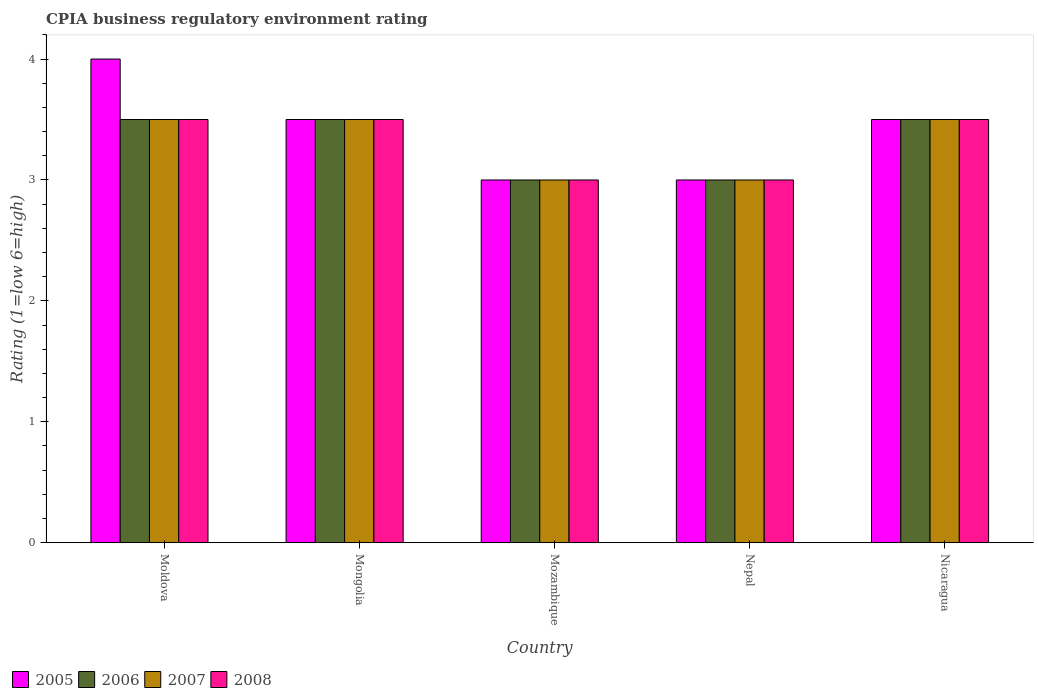How many different coloured bars are there?
Keep it short and to the point. 4. How many groups of bars are there?
Your answer should be compact. 5. How many bars are there on the 5th tick from the left?
Ensure brevity in your answer.  4. How many bars are there on the 1st tick from the right?
Provide a short and direct response. 4. What is the label of the 3rd group of bars from the left?
Your answer should be compact. Mozambique. In how many cases, is the number of bars for a given country not equal to the number of legend labels?
Provide a short and direct response. 0. In which country was the CPIA rating in 2008 maximum?
Offer a very short reply. Moldova. In which country was the CPIA rating in 2006 minimum?
Your response must be concise. Mozambique. What is the difference between the CPIA rating in 2006 in Moldova and that in Mongolia?
Your answer should be very brief. 0. What is the average CPIA rating in 2007 per country?
Offer a terse response. 3.3. What is the difference between the CPIA rating of/in 2006 and CPIA rating of/in 2007 in Mozambique?
Keep it short and to the point. 0. What is the ratio of the CPIA rating in 2005 in Mongolia to that in Mozambique?
Offer a terse response. 1.17. What is the difference between the highest and the lowest CPIA rating in 2007?
Your answer should be very brief. 0.5. Is the sum of the CPIA rating in 2006 in Nepal and Nicaragua greater than the maximum CPIA rating in 2008 across all countries?
Offer a terse response. Yes. Is it the case that in every country, the sum of the CPIA rating in 2007 and CPIA rating in 2006 is greater than the sum of CPIA rating in 2005 and CPIA rating in 2008?
Give a very brief answer. No. Is it the case that in every country, the sum of the CPIA rating in 2005 and CPIA rating in 2006 is greater than the CPIA rating in 2007?
Make the answer very short. Yes. Are all the bars in the graph horizontal?
Keep it short and to the point. No. How many countries are there in the graph?
Your answer should be very brief. 5. What is the difference between two consecutive major ticks on the Y-axis?
Make the answer very short. 1. Does the graph contain any zero values?
Your response must be concise. No. Does the graph contain grids?
Your response must be concise. No. How many legend labels are there?
Provide a succinct answer. 4. How are the legend labels stacked?
Offer a very short reply. Horizontal. What is the title of the graph?
Ensure brevity in your answer.  CPIA business regulatory environment rating. Does "2015" appear as one of the legend labels in the graph?
Your answer should be compact. No. What is the label or title of the X-axis?
Offer a terse response. Country. What is the Rating (1=low 6=high) in 2005 in Moldova?
Your response must be concise. 4. What is the Rating (1=low 6=high) of 2006 in Moldova?
Offer a very short reply. 3.5. What is the Rating (1=low 6=high) of 2007 in Moldova?
Give a very brief answer. 3.5. What is the Rating (1=low 6=high) of 2008 in Moldova?
Your answer should be compact. 3.5. What is the Rating (1=low 6=high) of 2005 in Mongolia?
Your answer should be very brief. 3.5. What is the Rating (1=low 6=high) of 2008 in Mongolia?
Offer a terse response. 3.5. What is the Rating (1=low 6=high) of 2005 in Mozambique?
Provide a short and direct response. 3. What is the Rating (1=low 6=high) of 2005 in Nepal?
Make the answer very short. 3. What is the Rating (1=low 6=high) in 2006 in Nepal?
Provide a succinct answer. 3. What is the Rating (1=low 6=high) of 2007 in Nicaragua?
Your answer should be very brief. 3.5. Across all countries, what is the maximum Rating (1=low 6=high) of 2005?
Offer a terse response. 4. Across all countries, what is the maximum Rating (1=low 6=high) of 2006?
Give a very brief answer. 3.5. Across all countries, what is the maximum Rating (1=low 6=high) of 2007?
Your answer should be compact. 3.5. Across all countries, what is the minimum Rating (1=low 6=high) of 2006?
Your answer should be compact. 3. What is the total Rating (1=low 6=high) in 2006 in the graph?
Offer a terse response. 16.5. What is the difference between the Rating (1=low 6=high) of 2005 in Moldova and that in Mongolia?
Provide a succinct answer. 0.5. What is the difference between the Rating (1=low 6=high) in 2006 in Moldova and that in Mongolia?
Your answer should be compact. 0. What is the difference between the Rating (1=low 6=high) in 2008 in Moldova and that in Mongolia?
Give a very brief answer. 0. What is the difference between the Rating (1=low 6=high) in 2005 in Moldova and that in Mozambique?
Your response must be concise. 1. What is the difference between the Rating (1=low 6=high) in 2006 in Moldova and that in Mozambique?
Your response must be concise. 0.5. What is the difference between the Rating (1=low 6=high) in 2007 in Moldova and that in Mozambique?
Give a very brief answer. 0.5. What is the difference between the Rating (1=low 6=high) of 2008 in Moldova and that in Mozambique?
Your answer should be compact. 0.5. What is the difference between the Rating (1=low 6=high) in 2005 in Moldova and that in Nepal?
Your answer should be compact. 1. What is the difference between the Rating (1=low 6=high) in 2008 in Moldova and that in Nepal?
Provide a short and direct response. 0.5. What is the difference between the Rating (1=low 6=high) in 2006 in Moldova and that in Nicaragua?
Your answer should be compact. 0. What is the difference between the Rating (1=low 6=high) in 2007 in Moldova and that in Nicaragua?
Your answer should be compact. 0. What is the difference between the Rating (1=low 6=high) in 2005 in Mongolia and that in Mozambique?
Give a very brief answer. 0.5. What is the difference between the Rating (1=low 6=high) of 2007 in Mongolia and that in Mozambique?
Ensure brevity in your answer.  0.5. What is the difference between the Rating (1=low 6=high) in 2006 in Mongolia and that in Nepal?
Provide a short and direct response. 0.5. What is the difference between the Rating (1=low 6=high) in 2006 in Mongolia and that in Nicaragua?
Offer a terse response. 0. What is the difference between the Rating (1=low 6=high) of 2005 in Mozambique and that in Nepal?
Provide a short and direct response. 0. What is the difference between the Rating (1=low 6=high) of 2007 in Mozambique and that in Nepal?
Give a very brief answer. 0. What is the difference between the Rating (1=low 6=high) in 2008 in Mozambique and that in Nepal?
Your answer should be compact. 0. What is the difference between the Rating (1=low 6=high) in 2005 in Mozambique and that in Nicaragua?
Your answer should be very brief. -0.5. What is the difference between the Rating (1=low 6=high) of 2006 in Mozambique and that in Nicaragua?
Give a very brief answer. -0.5. What is the difference between the Rating (1=low 6=high) of 2007 in Mozambique and that in Nicaragua?
Offer a terse response. -0.5. What is the difference between the Rating (1=low 6=high) in 2008 in Mozambique and that in Nicaragua?
Give a very brief answer. -0.5. What is the difference between the Rating (1=low 6=high) of 2006 in Nepal and that in Nicaragua?
Give a very brief answer. -0.5. What is the difference between the Rating (1=low 6=high) in 2008 in Nepal and that in Nicaragua?
Your answer should be compact. -0.5. What is the difference between the Rating (1=low 6=high) of 2005 in Moldova and the Rating (1=low 6=high) of 2006 in Mongolia?
Provide a succinct answer. 0.5. What is the difference between the Rating (1=low 6=high) of 2005 in Moldova and the Rating (1=low 6=high) of 2007 in Mongolia?
Your answer should be very brief. 0.5. What is the difference between the Rating (1=low 6=high) in 2005 in Moldova and the Rating (1=low 6=high) in 2006 in Mozambique?
Provide a succinct answer. 1. What is the difference between the Rating (1=low 6=high) of 2006 in Moldova and the Rating (1=low 6=high) of 2008 in Mozambique?
Provide a short and direct response. 0.5. What is the difference between the Rating (1=low 6=high) in 2007 in Moldova and the Rating (1=low 6=high) in 2008 in Mozambique?
Ensure brevity in your answer.  0.5. What is the difference between the Rating (1=low 6=high) in 2005 in Moldova and the Rating (1=low 6=high) in 2007 in Nepal?
Your answer should be compact. 1. What is the difference between the Rating (1=low 6=high) in 2006 in Moldova and the Rating (1=low 6=high) in 2007 in Nepal?
Your answer should be compact. 0.5. What is the difference between the Rating (1=low 6=high) of 2007 in Moldova and the Rating (1=low 6=high) of 2008 in Nepal?
Your answer should be very brief. 0.5. What is the difference between the Rating (1=low 6=high) in 2005 in Moldova and the Rating (1=low 6=high) in 2006 in Nicaragua?
Provide a succinct answer. 0.5. What is the difference between the Rating (1=low 6=high) in 2005 in Moldova and the Rating (1=low 6=high) in 2008 in Nicaragua?
Your answer should be compact. 0.5. What is the difference between the Rating (1=low 6=high) in 2005 in Mongolia and the Rating (1=low 6=high) in 2007 in Mozambique?
Your answer should be compact. 0.5. What is the difference between the Rating (1=low 6=high) in 2005 in Mongolia and the Rating (1=low 6=high) in 2008 in Mozambique?
Offer a very short reply. 0.5. What is the difference between the Rating (1=low 6=high) of 2006 in Mongolia and the Rating (1=low 6=high) of 2007 in Mozambique?
Offer a very short reply. 0.5. What is the difference between the Rating (1=low 6=high) of 2007 in Mongolia and the Rating (1=low 6=high) of 2008 in Mozambique?
Keep it short and to the point. 0.5. What is the difference between the Rating (1=low 6=high) of 2005 in Mongolia and the Rating (1=low 6=high) of 2007 in Nepal?
Provide a succinct answer. 0.5. What is the difference between the Rating (1=low 6=high) of 2006 in Mongolia and the Rating (1=low 6=high) of 2008 in Nepal?
Your answer should be compact. 0.5. What is the difference between the Rating (1=low 6=high) in 2005 in Mongolia and the Rating (1=low 6=high) in 2006 in Nicaragua?
Provide a short and direct response. 0. What is the difference between the Rating (1=low 6=high) in 2005 in Mongolia and the Rating (1=low 6=high) in 2008 in Nicaragua?
Offer a terse response. 0. What is the difference between the Rating (1=low 6=high) of 2007 in Mongolia and the Rating (1=low 6=high) of 2008 in Nicaragua?
Your answer should be very brief. 0. What is the difference between the Rating (1=low 6=high) in 2005 in Mozambique and the Rating (1=low 6=high) in 2008 in Nepal?
Your response must be concise. 0. What is the difference between the Rating (1=low 6=high) of 2006 in Mozambique and the Rating (1=low 6=high) of 2008 in Nepal?
Make the answer very short. 0. What is the difference between the Rating (1=low 6=high) in 2007 in Mozambique and the Rating (1=low 6=high) in 2008 in Nepal?
Your answer should be very brief. 0. What is the difference between the Rating (1=low 6=high) in 2005 in Mozambique and the Rating (1=low 6=high) in 2006 in Nicaragua?
Offer a very short reply. -0.5. What is the difference between the Rating (1=low 6=high) in 2005 in Mozambique and the Rating (1=low 6=high) in 2008 in Nicaragua?
Give a very brief answer. -0.5. What is the difference between the Rating (1=low 6=high) of 2006 in Mozambique and the Rating (1=low 6=high) of 2007 in Nicaragua?
Offer a very short reply. -0.5. What is the difference between the Rating (1=low 6=high) of 2006 in Mozambique and the Rating (1=low 6=high) of 2008 in Nicaragua?
Keep it short and to the point. -0.5. What is the difference between the Rating (1=low 6=high) in 2005 in Nepal and the Rating (1=low 6=high) in 2006 in Nicaragua?
Ensure brevity in your answer.  -0.5. What is the difference between the Rating (1=low 6=high) in 2005 in Nepal and the Rating (1=low 6=high) in 2007 in Nicaragua?
Offer a very short reply. -0.5. What is the difference between the Rating (1=low 6=high) of 2006 in Nepal and the Rating (1=low 6=high) of 2008 in Nicaragua?
Offer a terse response. -0.5. What is the average Rating (1=low 6=high) in 2006 per country?
Your answer should be compact. 3.3. What is the average Rating (1=low 6=high) in 2008 per country?
Provide a short and direct response. 3.3. What is the difference between the Rating (1=low 6=high) of 2005 and Rating (1=low 6=high) of 2007 in Moldova?
Provide a short and direct response. 0.5. What is the difference between the Rating (1=low 6=high) in 2005 and Rating (1=low 6=high) in 2008 in Moldova?
Your answer should be compact. 0.5. What is the difference between the Rating (1=low 6=high) of 2006 and Rating (1=low 6=high) of 2007 in Moldova?
Ensure brevity in your answer.  0. What is the difference between the Rating (1=low 6=high) of 2006 and Rating (1=low 6=high) of 2008 in Moldova?
Provide a short and direct response. 0. What is the difference between the Rating (1=low 6=high) of 2007 and Rating (1=low 6=high) of 2008 in Moldova?
Keep it short and to the point. 0. What is the difference between the Rating (1=low 6=high) in 2005 and Rating (1=low 6=high) in 2007 in Mongolia?
Your answer should be very brief. 0. What is the difference between the Rating (1=low 6=high) of 2005 and Rating (1=low 6=high) of 2008 in Mongolia?
Ensure brevity in your answer.  0. What is the difference between the Rating (1=low 6=high) of 2006 and Rating (1=low 6=high) of 2007 in Mongolia?
Your answer should be very brief. 0. What is the difference between the Rating (1=low 6=high) in 2005 and Rating (1=low 6=high) in 2006 in Mozambique?
Make the answer very short. 0. What is the difference between the Rating (1=low 6=high) of 2007 and Rating (1=low 6=high) of 2008 in Mozambique?
Provide a succinct answer. 0. What is the difference between the Rating (1=low 6=high) in 2005 and Rating (1=low 6=high) in 2006 in Nepal?
Offer a very short reply. 0. What is the difference between the Rating (1=low 6=high) in 2006 and Rating (1=low 6=high) in 2007 in Nepal?
Your answer should be compact. 0. What is the difference between the Rating (1=low 6=high) of 2007 and Rating (1=low 6=high) of 2008 in Nepal?
Offer a terse response. 0. What is the difference between the Rating (1=low 6=high) in 2005 and Rating (1=low 6=high) in 2006 in Nicaragua?
Your answer should be compact. 0. What is the difference between the Rating (1=low 6=high) in 2005 and Rating (1=low 6=high) in 2008 in Nicaragua?
Offer a very short reply. 0. What is the difference between the Rating (1=low 6=high) in 2007 and Rating (1=low 6=high) in 2008 in Nicaragua?
Make the answer very short. 0. What is the ratio of the Rating (1=low 6=high) of 2005 in Moldova to that in Mongolia?
Your answer should be compact. 1.14. What is the ratio of the Rating (1=low 6=high) of 2007 in Moldova to that in Mongolia?
Keep it short and to the point. 1. What is the ratio of the Rating (1=low 6=high) of 2005 in Moldova to that in Mozambique?
Make the answer very short. 1.33. What is the ratio of the Rating (1=low 6=high) of 2006 in Moldova to that in Mozambique?
Keep it short and to the point. 1.17. What is the ratio of the Rating (1=low 6=high) in 2007 in Moldova to that in Nepal?
Make the answer very short. 1.17. What is the ratio of the Rating (1=low 6=high) of 2005 in Moldova to that in Nicaragua?
Keep it short and to the point. 1.14. What is the ratio of the Rating (1=low 6=high) of 2008 in Moldova to that in Nicaragua?
Your response must be concise. 1. What is the ratio of the Rating (1=low 6=high) of 2008 in Mongolia to that in Mozambique?
Keep it short and to the point. 1.17. What is the ratio of the Rating (1=low 6=high) of 2006 in Mongolia to that in Nepal?
Offer a very short reply. 1.17. What is the ratio of the Rating (1=low 6=high) of 2007 in Mongolia to that in Nepal?
Provide a short and direct response. 1.17. What is the ratio of the Rating (1=low 6=high) of 2008 in Mongolia to that in Nepal?
Give a very brief answer. 1.17. What is the ratio of the Rating (1=low 6=high) in 2006 in Mozambique to that in Nepal?
Your answer should be very brief. 1. What is the ratio of the Rating (1=low 6=high) of 2007 in Mozambique to that in Nepal?
Provide a succinct answer. 1. What is the ratio of the Rating (1=low 6=high) in 2008 in Mozambique to that in Nepal?
Provide a succinct answer. 1. What is the ratio of the Rating (1=low 6=high) in 2006 in Mozambique to that in Nicaragua?
Your answer should be compact. 0.86. What is the ratio of the Rating (1=low 6=high) in 2007 in Mozambique to that in Nicaragua?
Your answer should be very brief. 0.86. What is the ratio of the Rating (1=low 6=high) in 2008 in Nepal to that in Nicaragua?
Offer a very short reply. 0.86. What is the difference between the highest and the second highest Rating (1=low 6=high) in 2005?
Keep it short and to the point. 0.5. What is the difference between the highest and the second highest Rating (1=low 6=high) in 2006?
Your answer should be very brief. 0. What is the difference between the highest and the second highest Rating (1=low 6=high) of 2008?
Provide a succinct answer. 0. What is the difference between the highest and the lowest Rating (1=low 6=high) in 2006?
Provide a short and direct response. 0.5. What is the difference between the highest and the lowest Rating (1=low 6=high) in 2007?
Your answer should be very brief. 0.5. What is the difference between the highest and the lowest Rating (1=low 6=high) in 2008?
Offer a very short reply. 0.5. 